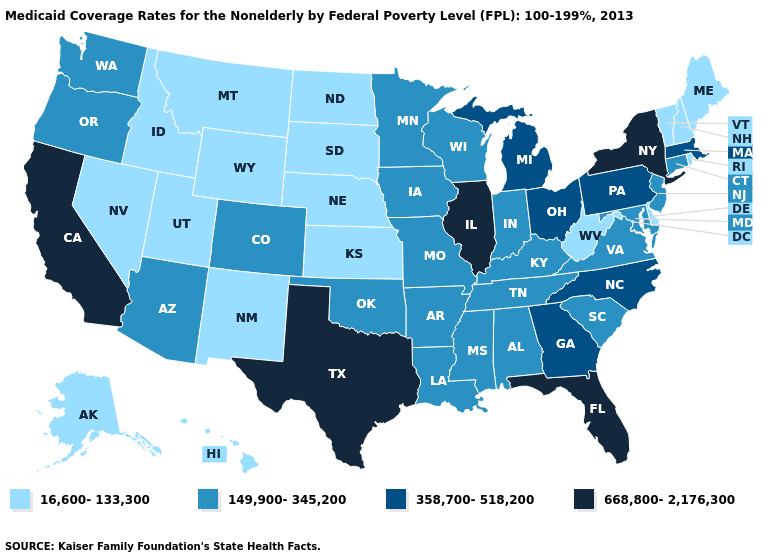Which states have the lowest value in the West?
Concise answer only. Alaska, Hawaii, Idaho, Montana, Nevada, New Mexico, Utah, Wyoming. What is the highest value in states that border Louisiana?
Give a very brief answer. 668,800-2,176,300. What is the highest value in states that border Vermont?
Answer briefly. 668,800-2,176,300. Does New Mexico have a higher value than Vermont?
Concise answer only. No. What is the value of Kansas?
Answer briefly. 16,600-133,300. Name the states that have a value in the range 149,900-345,200?
Quick response, please. Alabama, Arizona, Arkansas, Colorado, Connecticut, Indiana, Iowa, Kentucky, Louisiana, Maryland, Minnesota, Mississippi, Missouri, New Jersey, Oklahoma, Oregon, South Carolina, Tennessee, Virginia, Washington, Wisconsin. Among the states that border Washington , which have the lowest value?
Be succinct. Idaho. Does Pennsylvania have the same value as Missouri?
Give a very brief answer. No. Does Missouri have a lower value than North Carolina?
Quick response, please. Yes. Among the states that border Utah , does Nevada have the lowest value?
Give a very brief answer. Yes. What is the value of Hawaii?
Concise answer only. 16,600-133,300. Does Oregon have the lowest value in the West?
Write a very short answer. No. What is the value of Oregon?
Short answer required. 149,900-345,200. Name the states that have a value in the range 668,800-2,176,300?
Give a very brief answer. California, Florida, Illinois, New York, Texas. Name the states that have a value in the range 16,600-133,300?
Short answer required. Alaska, Delaware, Hawaii, Idaho, Kansas, Maine, Montana, Nebraska, Nevada, New Hampshire, New Mexico, North Dakota, Rhode Island, South Dakota, Utah, Vermont, West Virginia, Wyoming. 